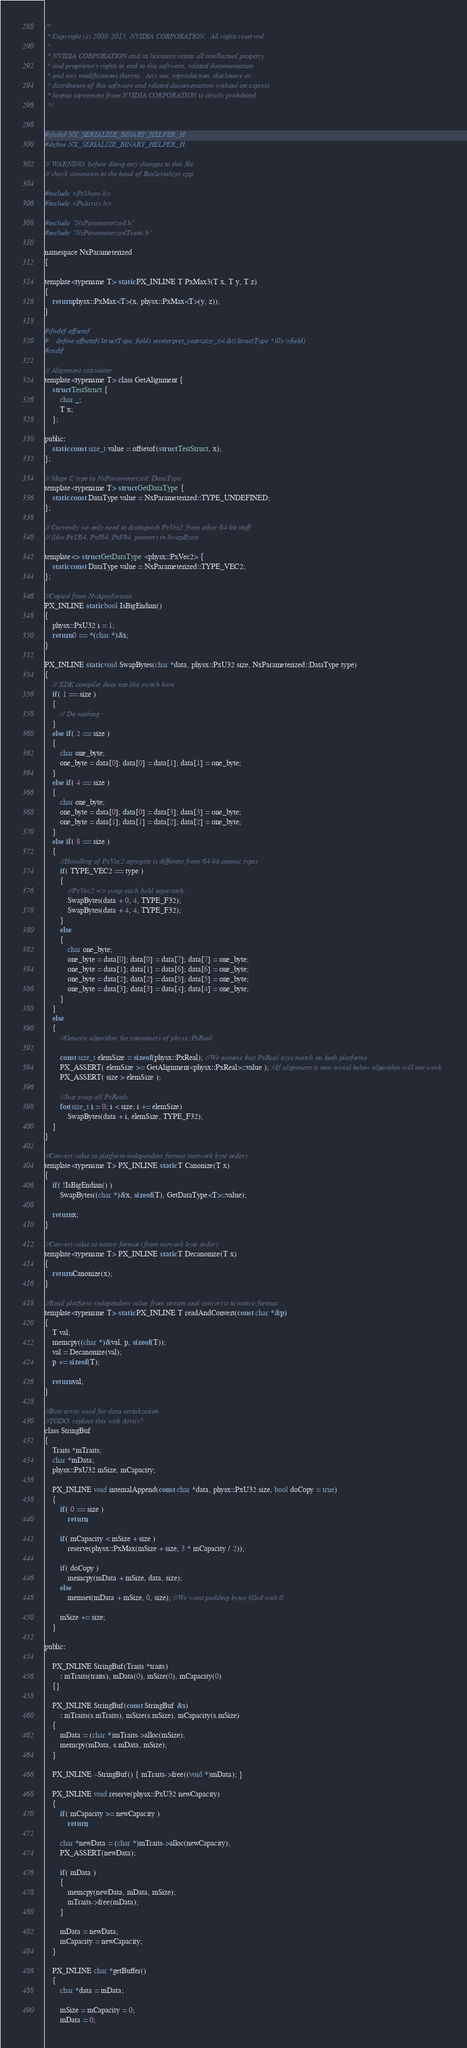Convert code to text. <code><loc_0><loc_0><loc_500><loc_500><_C_>/*
 * Copyright (c) 2008-2015, NVIDIA CORPORATION.  All rights reserved.
 *
 * NVIDIA CORPORATION and its licensors retain all intellectual property
 * and proprietary rights in and to this software, related documentation
 * and any modifications thereto.  Any use, reproduction, disclosure or
 * distribution of this software and related documentation without an express
 * license agreement from NVIDIA CORPORATION is strictly prohibited.
 */


#ifndef NX_SERIALIZE_BINARY_HELPER_H
#define NX_SERIALIZE_BINARY_HELPER_H

// WARNING: before doing any changes to this file
// check comments at the head of BinSerializer.cpp

#include <PsShare.h>
#include <PsArray.h>

#include "NxParameterized.h"
#include "NxParameterizedTraits.h"

namespace NxParameterized
{

template<typename T> static PX_INLINE T PxMax3(T x, T y, T z)
{
	return physx::PxMax<T>(x, physx::PxMax<T>(y, z));
}

#ifndef offsetof
#	define offsetof(StructType, field) reinterpret_cast<size_t>(&((StructType *)0)->field)
#endif

// Alignment calculator
template<typename T> class GetAlignment {
	struct TestStruct {
		char _;
		T x;
	};

public:
	static const size_t value = offsetof(struct TestStruct, x);
};

// Maps C type to NxParameterized::DataType
template<typename T> struct GetDataType {
	static const DataType value = NxParameterized::TYPE_UNDEFINED;
};

// Currently we only need to distinguish PxVec2 from other 64-bit stuff
// (like PxU64, PxI64, PxF64, pointer) in SwapBytes

template<> struct GetDataType <physx::PxVec2> {
	static const DataType value = NxParameterized::TYPE_VEC2;
};

//Copied from NvApexStream
PX_INLINE static bool IsBigEndian()
{
	physx::PxU32 i = 1;
	return 0 == *(char *)&i;
}

PX_INLINE static void SwapBytes(char *data, physx::PxU32 size, NxParameterized::DataType type)
{
	// XDK compiler does not like switch here
	if( 1 == size )
	{
		// Do nothing
	}
	else if( 2 == size )
	{
		char one_byte;
		one_byte = data[0]; data[0] = data[1]; data[1] = one_byte;
	}
	else if( 4 == size )
	{
		char one_byte;
		one_byte = data[0]; data[0] = data[3]; data[3] = one_byte;
		one_byte = data[1]; data[1] = data[2]; data[2] = one_byte;
	}
	else if( 8 == size )
	{
		//Handling of PxVec2 agregate is different from 64-bit atomic types
		if( TYPE_VEC2 == type )
		{
			//PxVec2 => swap each field separately
			SwapBytes(data + 0, 4, TYPE_F32);
			SwapBytes(data + 4, 4, TYPE_F32);
		}
		else
		{
			char one_byte;
			one_byte = data[0]; data[0] = data[7]; data[7] = one_byte;
			one_byte = data[1]; data[1] = data[6]; data[6] = one_byte;
			one_byte = data[2]; data[2] = data[5]; data[5] = one_byte;
			one_byte = data[3]; data[3] = data[4]; data[4] = one_byte;
		}
	}
	else
	{
		//Generic algorithm for containers of physx::PxReal

		const size_t elemSize = sizeof(physx::PxReal); //We assume that PxReal sizes match on both platforms
		PX_ASSERT( elemSize >= GetAlignment<physx::PxReal>::value ); //If alignment is non-trivial below algorithm will not work
		PX_ASSERT( size > elemSize );

		//Just swap all PxReals
		for(size_t i = 0; i < size; i += elemSize)
			SwapBytes(data + i, elemSize, TYPE_F32);
	}
}

//Convert value to platform-independent format (network byte order)
template<typename T> PX_INLINE static T Canonize(T x)
{
	if( !IsBigEndian() )
		SwapBytes((char *)&x, sizeof(T), GetDataType<T>::value);

	return x;
}

//Convert value to native format (from network byte order)
template<typename T> PX_INLINE static T Decanonize(T x)
{
	return Canonize(x);
}

//Read platform-independent value from stream and convert it to native format
template<typename T> static PX_INLINE T readAndConvert(const char *&p)
{
	T val;
	memcpy((char *)&val, p, sizeof(T));
	val = Decanonize(val);
	p += sizeof(T);

	return val;
}

//Byte array used for data serialization
//TODO: replace this with Array?
class StringBuf
{
	Traits *mTraits;
	char *mData;
	physx::PxU32 mSize, mCapacity;

	PX_INLINE void internalAppend(const char *data, physx::PxU32 size, bool doCopy = true)
	{
		if( 0 == size )
			return;

		if( mCapacity < mSize + size )
			reserve(physx::PxMax(mSize + size, 3 * mCapacity / 2));

		if( doCopy )
			memcpy(mData + mSize, data, size);
		else
			memset(mData + mSize, 0, size); //We want padding bytes filled with 0

		mSize += size;
	}

public:

	PX_INLINE StringBuf(Traits *traits)
		: mTraits(traits), mData(0), mSize(0), mCapacity(0)
	{}

	PX_INLINE StringBuf(const StringBuf &s)
		: mTraits(s.mTraits), mSize(s.mSize), mCapacity(s.mSize)
	{
		mData = (char *)mTraits->alloc(mSize);
		memcpy(mData, s.mData, mSize);
	}

	PX_INLINE ~StringBuf() { mTraits->free((void *)mData); }

	PX_INLINE void reserve(physx::PxU32 newCapacity)
	{
		if( mCapacity >= newCapacity )
			return;

		char *newData = (char *)mTraits->alloc(newCapacity);
		PX_ASSERT(newData);

		if( mData )
		{
			memcpy(newData, mData, mSize);
			mTraits->free(mData);
		}

		mData = newData;
		mCapacity = newCapacity;
	}

	PX_INLINE char *getBuffer()
	{
		char *data = mData;

		mSize = mCapacity = 0;
		mData = 0;
</code> 